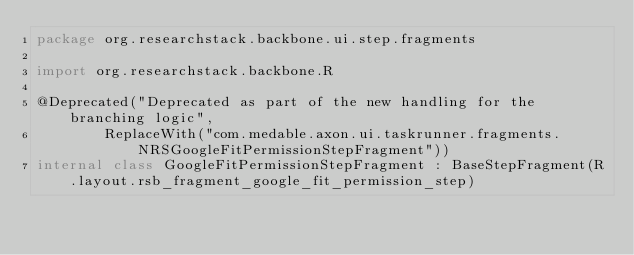Convert code to text. <code><loc_0><loc_0><loc_500><loc_500><_Kotlin_>package org.researchstack.backbone.ui.step.fragments

import org.researchstack.backbone.R

@Deprecated("Deprecated as part of the new handling for the branching logic",
        ReplaceWith("com.medable.axon.ui.taskrunner.fragments.NRSGoogleFitPermissionStepFragment"))
internal class GoogleFitPermissionStepFragment : BaseStepFragment(R.layout.rsb_fragment_google_fit_permission_step)</code> 